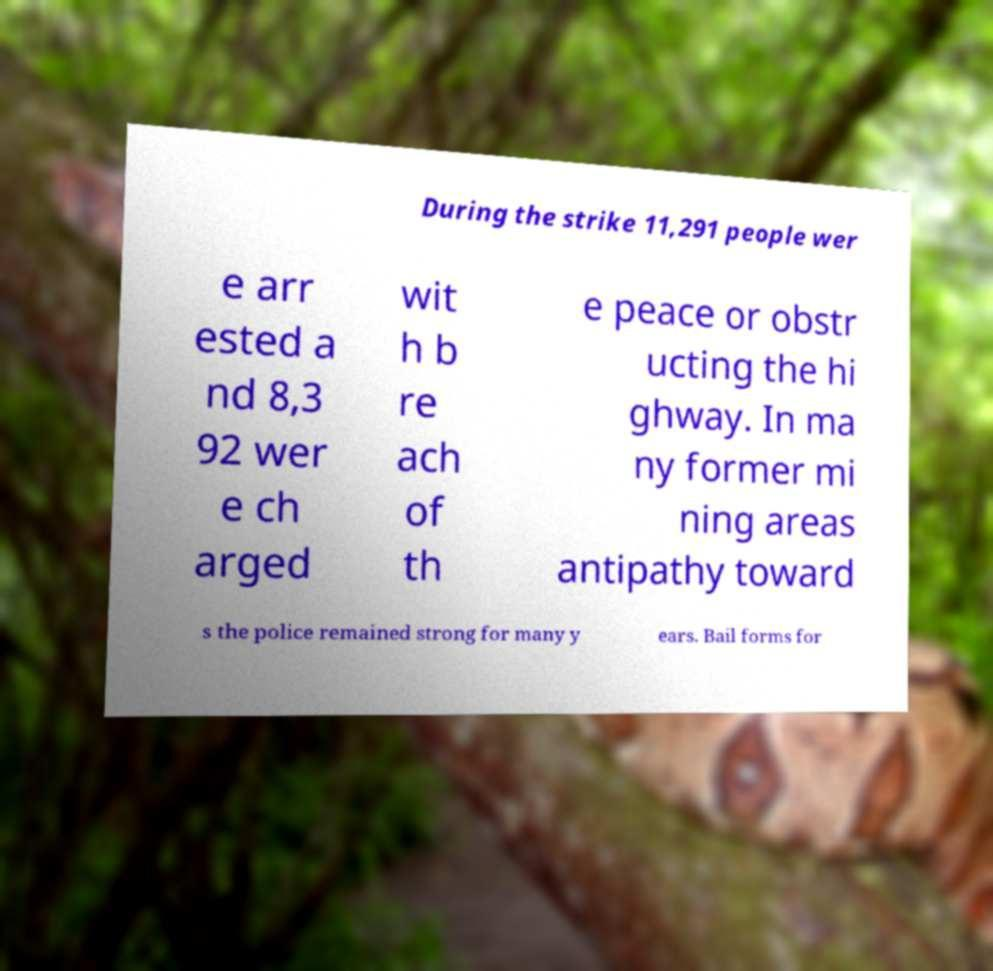There's text embedded in this image that I need extracted. Can you transcribe it verbatim? During the strike 11,291 people wer e arr ested a nd 8,3 92 wer e ch arged wit h b re ach of th e peace or obstr ucting the hi ghway. In ma ny former mi ning areas antipathy toward s the police remained strong for many y ears. Bail forms for 